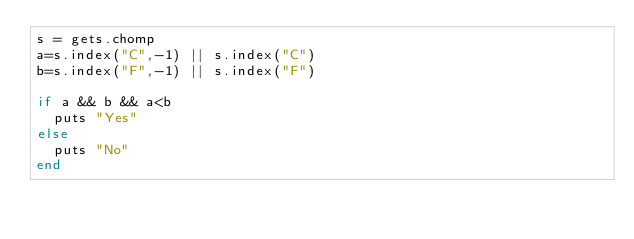Convert code to text. <code><loc_0><loc_0><loc_500><loc_500><_Ruby_>s = gets.chomp
a=s.index("C",-1) || s.index("C")
b=s.index("F",-1) || s.index("F")

if a && b && a<b
  puts "Yes"
else
  puts "No"
end
</code> 